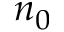<formula> <loc_0><loc_0><loc_500><loc_500>n _ { 0 }</formula> 